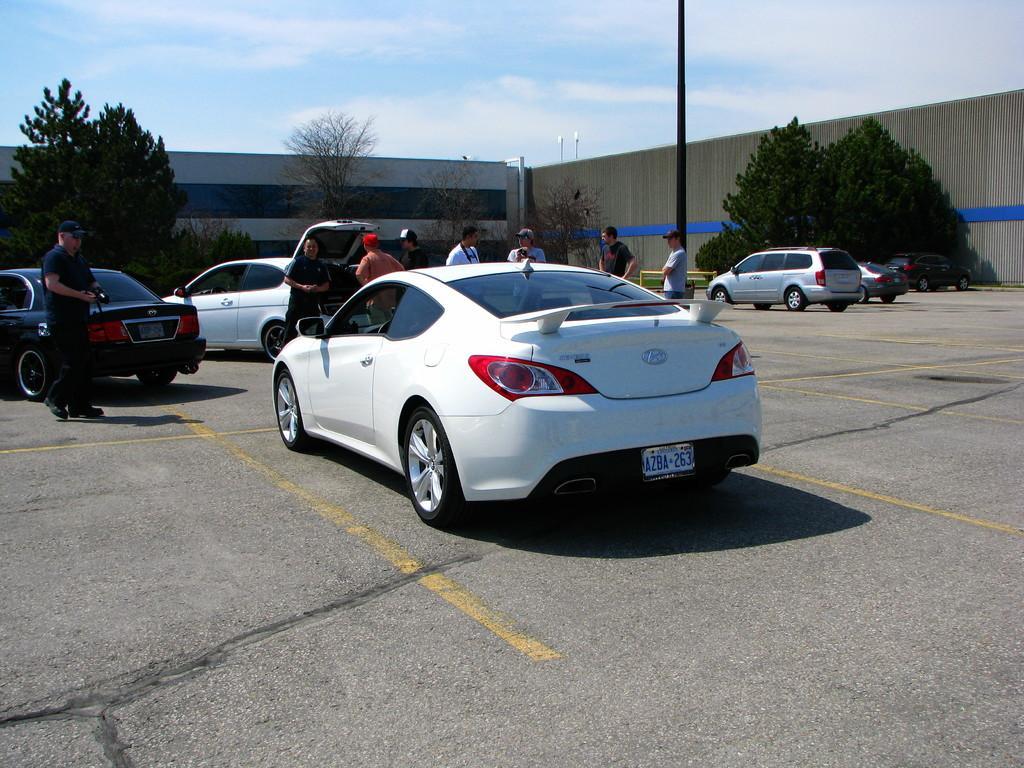In one or two sentences, can you explain what this image depicts? In this image I can see few vehicles are on the road. And I can see the group of people standing and wearing the different color dresses. In the background there are many trees and also the wall. I can also see the clouds and also the blue sky. 